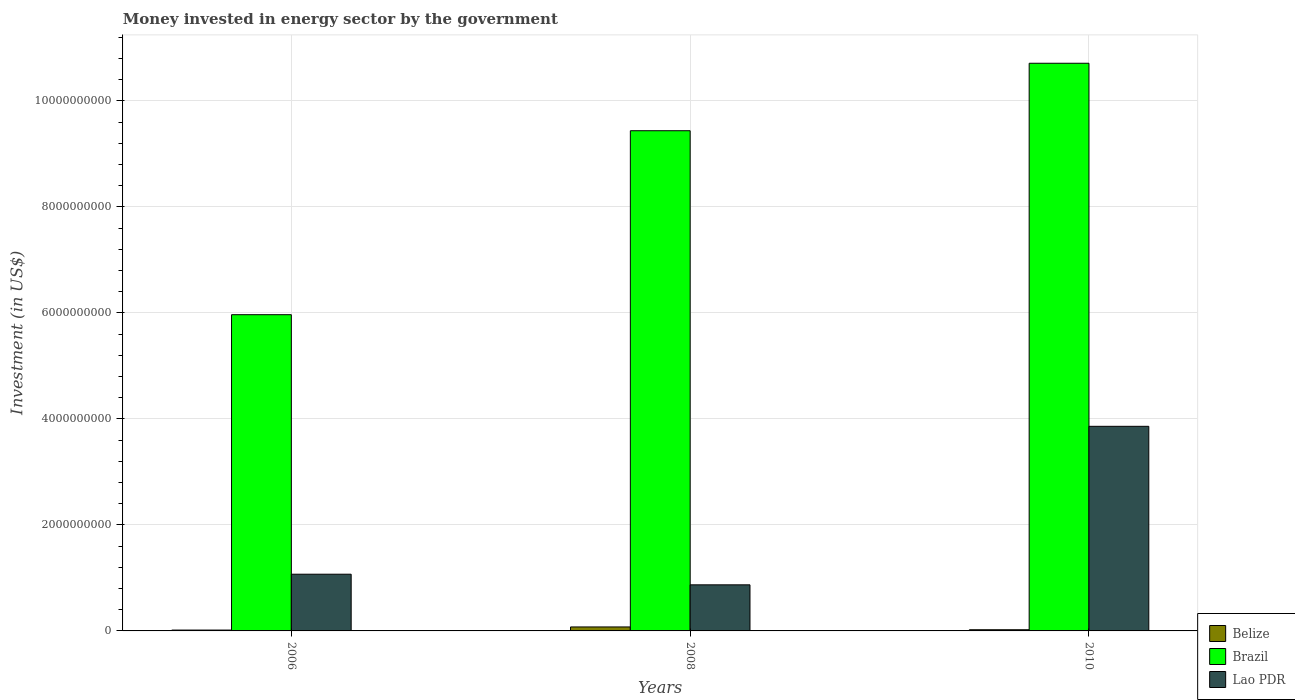How many different coloured bars are there?
Provide a short and direct response. 3. How many groups of bars are there?
Your answer should be compact. 3. Are the number of bars per tick equal to the number of legend labels?
Offer a very short reply. Yes. Are the number of bars on each tick of the X-axis equal?
Ensure brevity in your answer.  Yes. What is the money spent in energy sector in Brazil in 2008?
Offer a very short reply. 9.44e+09. Across all years, what is the maximum money spent in energy sector in Brazil?
Your answer should be compact. 1.07e+1. Across all years, what is the minimum money spent in energy sector in Belize?
Make the answer very short. 1.60e+07. What is the total money spent in energy sector in Belize in the graph?
Your answer should be compact. 1.13e+08. What is the difference between the money spent in energy sector in Brazil in 2006 and that in 2008?
Offer a very short reply. -3.47e+09. What is the difference between the money spent in energy sector in Belize in 2008 and the money spent in energy sector in Lao PDR in 2010?
Offer a terse response. -3.78e+09. What is the average money spent in energy sector in Belize per year?
Provide a short and direct response. 3.77e+07. In the year 2006, what is the difference between the money spent in energy sector in Brazil and money spent in energy sector in Belize?
Give a very brief answer. 5.95e+09. In how many years, is the money spent in energy sector in Brazil greater than 10400000000 US$?
Give a very brief answer. 1. What is the ratio of the money spent in energy sector in Brazil in 2008 to that in 2010?
Make the answer very short. 0.88. Is the money spent in energy sector in Brazil in 2006 less than that in 2008?
Your answer should be compact. Yes. Is the difference between the money spent in energy sector in Brazil in 2006 and 2008 greater than the difference between the money spent in energy sector in Belize in 2006 and 2008?
Make the answer very short. No. What is the difference between the highest and the second highest money spent in energy sector in Lao PDR?
Offer a very short reply. 2.79e+09. What is the difference between the highest and the lowest money spent in energy sector in Brazil?
Provide a succinct answer. 4.74e+09. In how many years, is the money spent in energy sector in Belize greater than the average money spent in energy sector in Belize taken over all years?
Your answer should be very brief. 1. What does the 1st bar from the left in 2006 represents?
Offer a terse response. Belize. What does the 3rd bar from the right in 2010 represents?
Keep it short and to the point. Belize. How many bars are there?
Make the answer very short. 9. How many years are there in the graph?
Your answer should be very brief. 3. Does the graph contain any zero values?
Ensure brevity in your answer.  No. Where does the legend appear in the graph?
Your response must be concise. Bottom right. How are the legend labels stacked?
Your answer should be very brief. Vertical. What is the title of the graph?
Offer a very short reply. Money invested in energy sector by the government. Does "Turks and Caicos Islands" appear as one of the legend labels in the graph?
Offer a very short reply. No. What is the label or title of the X-axis?
Give a very brief answer. Years. What is the label or title of the Y-axis?
Give a very brief answer. Investment (in US$). What is the Investment (in US$) in Belize in 2006?
Give a very brief answer. 1.60e+07. What is the Investment (in US$) of Brazil in 2006?
Provide a succinct answer. 5.97e+09. What is the Investment (in US$) in Lao PDR in 2006?
Your answer should be very brief. 1.07e+09. What is the Investment (in US$) of Belize in 2008?
Offer a terse response. 7.50e+07. What is the Investment (in US$) of Brazil in 2008?
Ensure brevity in your answer.  9.44e+09. What is the Investment (in US$) in Lao PDR in 2008?
Your answer should be compact. 8.70e+08. What is the Investment (in US$) in Belize in 2010?
Your answer should be very brief. 2.22e+07. What is the Investment (in US$) in Brazil in 2010?
Give a very brief answer. 1.07e+1. What is the Investment (in US$) in Lao PDR in 2010?
Give a very brief answer. 3.86e+09. Across all years, what is the maximum Investment (in US$) in Belize?
Your response must be concise. 7.50e+07. Across all years, what is the maximum Investment (in US$) in Brazil?
Provide a succinct answer. 1.07e+1. Across all years, what is the maximum Investment (in US$) in Lao PDR?
Your response must be concise. 3.86e+09. Across all years, what is the minimum Investment (in US$) of Belize?
Provide a succinct answer. 1.60e+07. Across all years, what is the minimum Investment (in US$) in Brazil?
Give a very brief answer. 5.97e+09. Across all years, what is the minimum Investment (in US$) in Lao PDR?
Offer a very short reply. 8.70e+08. What is the total Investment (in US$) of Belize in the graph?
Your response must be concise. 1.13e+08. What is the total Investment (in US$) in Brazil in the graph?
Your answer should be compact. 2.61e+1. What is the total Investment (in US$) in Lao PDR in the graph?
Your answer should be compact. 5.80e+09. What is the difference between the Investment (in US$) of Belize in 2006 and that in 2008?
Make the answer very short. -5.90e+07. What is the difference between the Investment (in US$) in Brazil in 2006 and that in 2008?
Make the answer very short. -3.47e+09. What is the difference between the Investment (in US$) in Lao PDR in 2006 and that in 2008?
Provide a succinct answer. 2.00e+08. What is the difference between the Investment (in US$) of Belize in 2006 and that in 2010?
Provide a short and direct response. -6.20e+06. What is the difference between the Investment (in US$) of Brazil in 2006 and that in 2010?
Ensure brevity in your answer.  -4.74e+09. What is the difference between the Investment (in US$) in Lao PDR in 2006 and that in 2010?
Keep it short and to the point. -2.79e+09. What is the difference between the Investment (in US$) in Belize in 2008 and that in 2010?
Make the answer very short. 5.28e+07. What is the difference between the Investment (in US$) in Brazil in 2008 and that in 2010?
Provide a short and direct response. -1.27e+09. What is the difference between the Investment (in US$) in Lao PDR in 2008 and that in 2010?
Your answer should be compact. -2.99e+09. What is the difference between the Investment (in US$) in Belize in 2006 and the Investment (in US$) in Brazil in 2008?
Ensure brevity in your answer.  -9.42e+09. What is the difference between the Investment (in US$) of Belize in 2006 and the Investment (in US$) of Lao PDR in 2008?
Your answer should be compact. -8.54e+08. What is the difference between the Investment (in US$) of Brazil in 2006 and the Investment (in US$) of Lao PDR in 2008?
Provide a short and direct response. 5.10e+09. What is the difference between the Investment (in US$) in Belize in 2006 and the Investment (in US$) in Brazil in 2010?
Make the answer very short. -1.07e+1. What is the difference between the Investment (in US$) in Belize in 2006 and the Investment (in US$) in Lao PDR in 2010?
Your answer should be compact. -3.84e+09. What is the difference between the Investment (in US$) of Brazil in 2006 and the Investment (in US$) of Lao PDR in 2010?
Make the answer very short. 2.11e+09. What is the difference between the Investment (in US$) of Belize in 2008 and the Investment (in US$) of Brazil in 2010?
Provide a succinct answer. -1.06e+1. What is the difference between the Investment (in US$) in Belize in 2008 and the Investment (in US$) in Lao PDR in 2010?
Provide a succinct answer. -3.78e+09. What is the difference between the Investment (in US$) of Brazil in 2008 and the Investment (in US$) of Lao PDR in 2010?
Your answer should be very brief. 5.58e+09. What is the average Investment (in US$) of Belize per year?
Your answer should be compact. 3.77e+07. What is the average Investment (in US$) in Brazil per year?
Make the answer very short. 8.70e+09. What is the average Investment (in US$) of Lao PDR per year?
Keep it short and to the point. 1.93e+09. In the year 2006, what is the difference between the Investment (in US$) in Belize and Investment (in US$) in Brazil?
Provide a succinct answer. -5.95e+09. In the year 2006, what is the difference between the Investment (in US$) in Belize and Investment (in US$) in Lao PDR?
Your answer should be very brief. -1.05e+09. In the year 2006, what is the difference between the Investment (in US$) of Brazil and Investment (in US$) of Lao PDR?
Keep it short and to the point. 4.90e+09. In the year 2008, what is the difference between the Investment (in US$) in Belize and Investment (in US$) in Brazil?
Provide a short and direct response. -9.36e+09. In the year 2008, what is the difference between the Investment (in US$) of Belize and Investment (in US$) of Lao PDR?
Keep it short and to the point. -7.94e+08. In the year 2008, what is the difference between the Investment (in US$) in Brazil and Investment (in US$) in Lao PDR?
Offer a terse response. 8.57e+09. In the year 2010, what is the difference between the Investment (in US$) of Belize and Investment (in US$) of Brazil?
Offer a terse response. -1.07e+1. In the year 2010, what is the difference between the Investment (in US$) of Belize and Investment (in US$) of Lao PDR?
Provide a succinct answer. -3.84e+09. In the year 2010, what is the difference between the Investment (in US$) of Brazil and Investment (in US$) of Lao PDR?
Offer a terse response. 6.85e+09. What is the ratio of the Investment (in US$) of Belize in 2006 to that in 2008?
Ensure brevity in your answer.  0.21. What is the ratio of the Investment (in US$) of Brazil in 2006 to that in 2008?
Provide a short and direct response. 0.63. What is the ratio of the Investment (in US$) in Lao PDR in 2006 to that in 2008?
Offer a terse response. 1.23. What is the ratio of the Investment (in US$) of Belize in 2006 to that in 2010?
Give a very brief answer. 0.72. What is the ratio of the Investment (in US$) of Brazil in 2006 to that in 2010?
Provide a short and direct response. 0.56. What is the ratio of the Investment (in US$) in Lao PDR in 2006 to that in 2010?
Provide a short and direct response. 0.28. What is the ratio of the Investment (in US$) of Belize in 2008 to that in 2010?
Provide a short and direct response. 3.38. What is the ratio of the Investment (in US$) of Brazil in 2008 to that in 2010?
Provide a short and direct response. 0.88. What is the ratio of the Investment (in US$) in Lao PDR in 2008 to that in 2010?
Your answer should be very brief. 0.23. What is the difference between the highest and the second highest Investment (in US$) of Belize?
Offer a very short reply. 5.28e+07. What is the difference between the highest and the second highest Investment (in US$) of Brazil?
Your response must be concise. 1.27e+09. What is the difference between the highest and the second highest Investment (in US$) in Lao PDR?
Provide a short and direct response. 2.79e+09. What is the difference between the highest and the lowest Investment (in US$) of Belize?
Your answer should be compact. 5.90e+07. What is the difference between the highest and the lowest Investment (in US$) in Brazil?
Give a very brief answer. 4.74e+09. What is the difference between the highest and the lowest Investment (in US$) in Lao PDR?
Your response must be concise. 2.99e+09. 